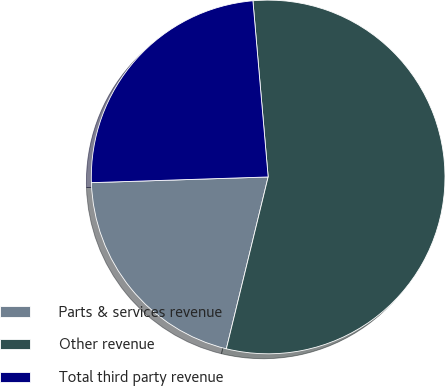<chart> <loc_0><loc_0><loc_500><loc_500><pie_chart><fcel>Parts & services revenue<fcel>Other revenue<fcel>Total third party revenue<nl><fcel>20.69%<fcel>55.17%<fcel>24.14%<nl></chart> 